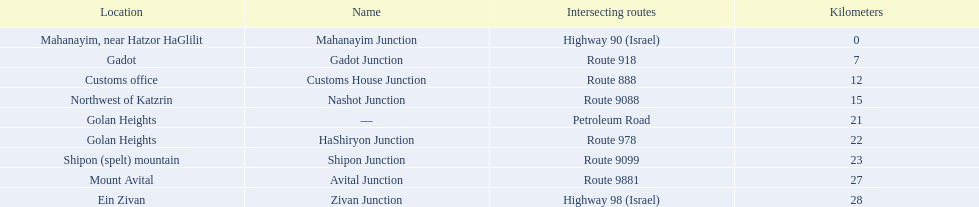How many kilometers away is shipon junction? 23. How many kilometers away is avital junction? 27. Which one is closer to nashot junction? Shipon Junction. 